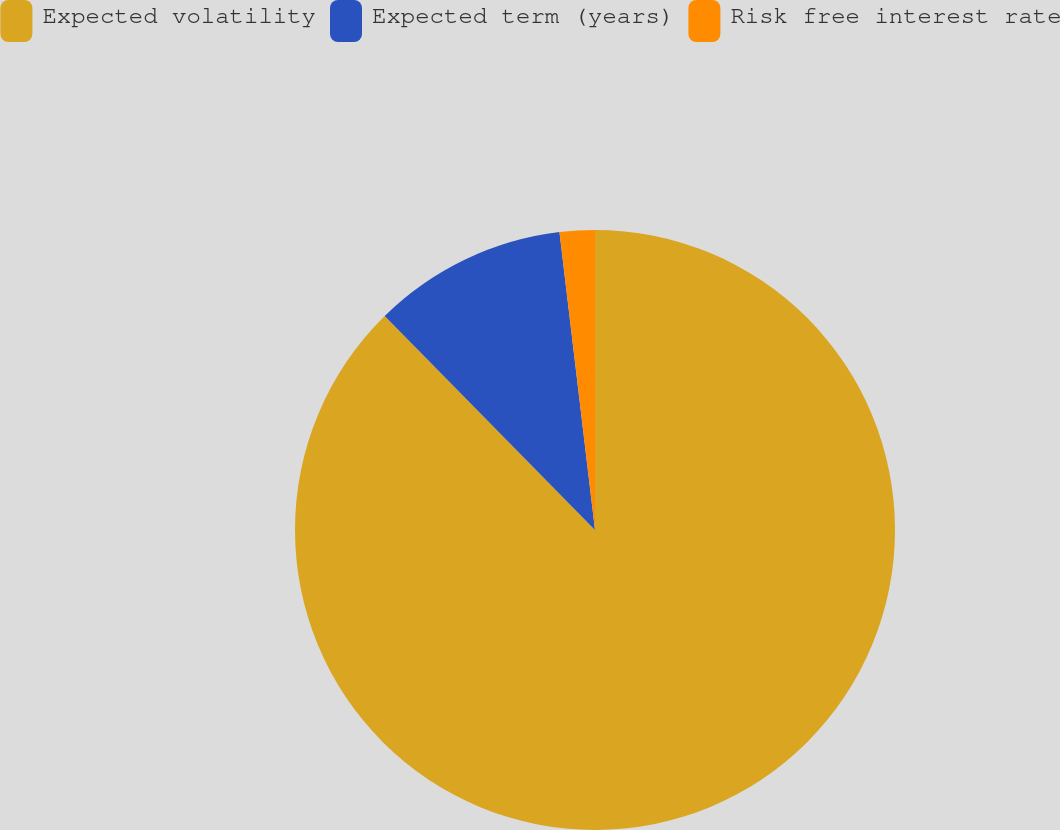<chart> <loc_0><loc_0><loc_500><loc_500><pie_chart><fcel>Expected volatility<fcel>Expected term (years)<fcel>Risk free interest rate<nl><fcel>87.63%<fcel>10.47%<fcel>1.89%<nl></chart> 